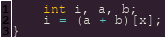Convert code to text. <code><loc_0><loc_0><loc_500><loc_500><_C_>	int i, a, b;
	i = (a + b)[x];
}
</code> 